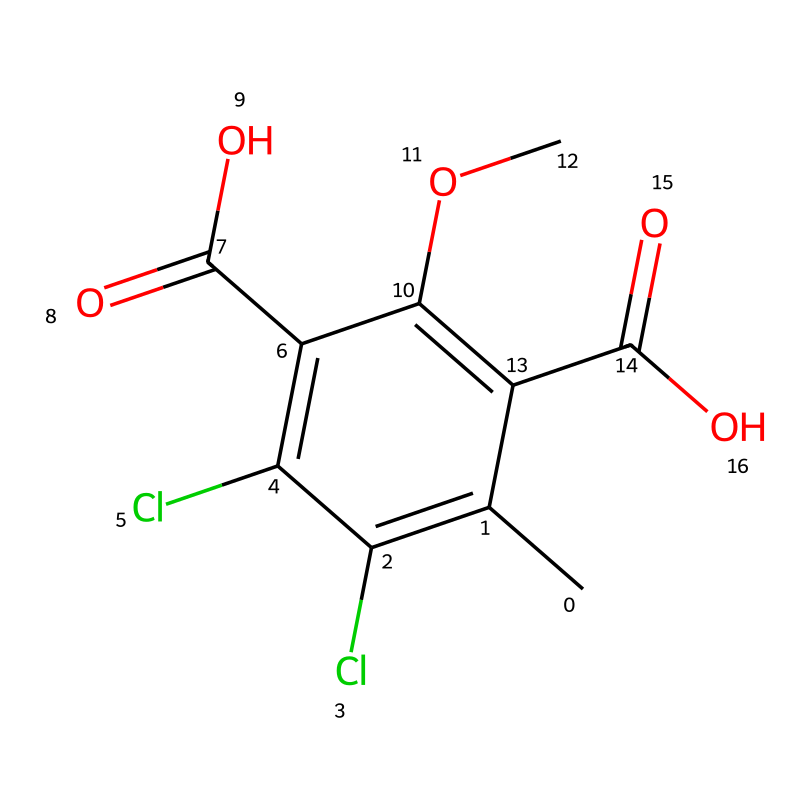How many carbon atoms are present in this chemical structure? By analyzing the SMILES representation, we count the number of 'C' characters. There are a total of 8 carbon atoms as denoted by the 'C' in the structure.
Answer: 8 What functional groups are found in this herbicide? The structure contains carboxylic acid functional groups denoted by 'C(=O)O' and an ether group indicated by 'OC'. Two carboxylic acids and one ether are present.
Answer: two carboxylic acids, one ether How many chlorine atoms are present in the chemical structure? By examining the SMILES representation, we count the number of 'Cl' characters. There are 2 chlorine atoms as specified in the structure.
Answer: 2 What is the molecular weight of dicamba? Using the atomic weights of carbon, hydrogen, oxygen, and chlorine, we can calculate the molecular weight based on the number of each atom present. The calculated molecular weight of dicamba is approximately 221.03 g/mol.
Answer: 221.03 g/mol What is the significance of the multiple functional groups in dicamba? The presence of multiple functional groups such as the carboxylic acids contributes to dicamba's herbicidal properties. These functional groups increase the chemical’s solubility in water and its ability to interact with plant biochemistry effectively.
Answer: herbicidal properties What type of herbicide is dicamba classified as? Dicamba is classified as a benzoic acid herbicide, which is indicated by the presence of a benzene ring and a carboxylic acid in its structure.
Answer: benzoic acid herbicide What role does the ether group play in the herbicide's activity? The ether group enhances the solubility and stability of dicamba in formulations, which improves its ability to be absorbed by plants when applied.
Answer: enhances solubility and stability 